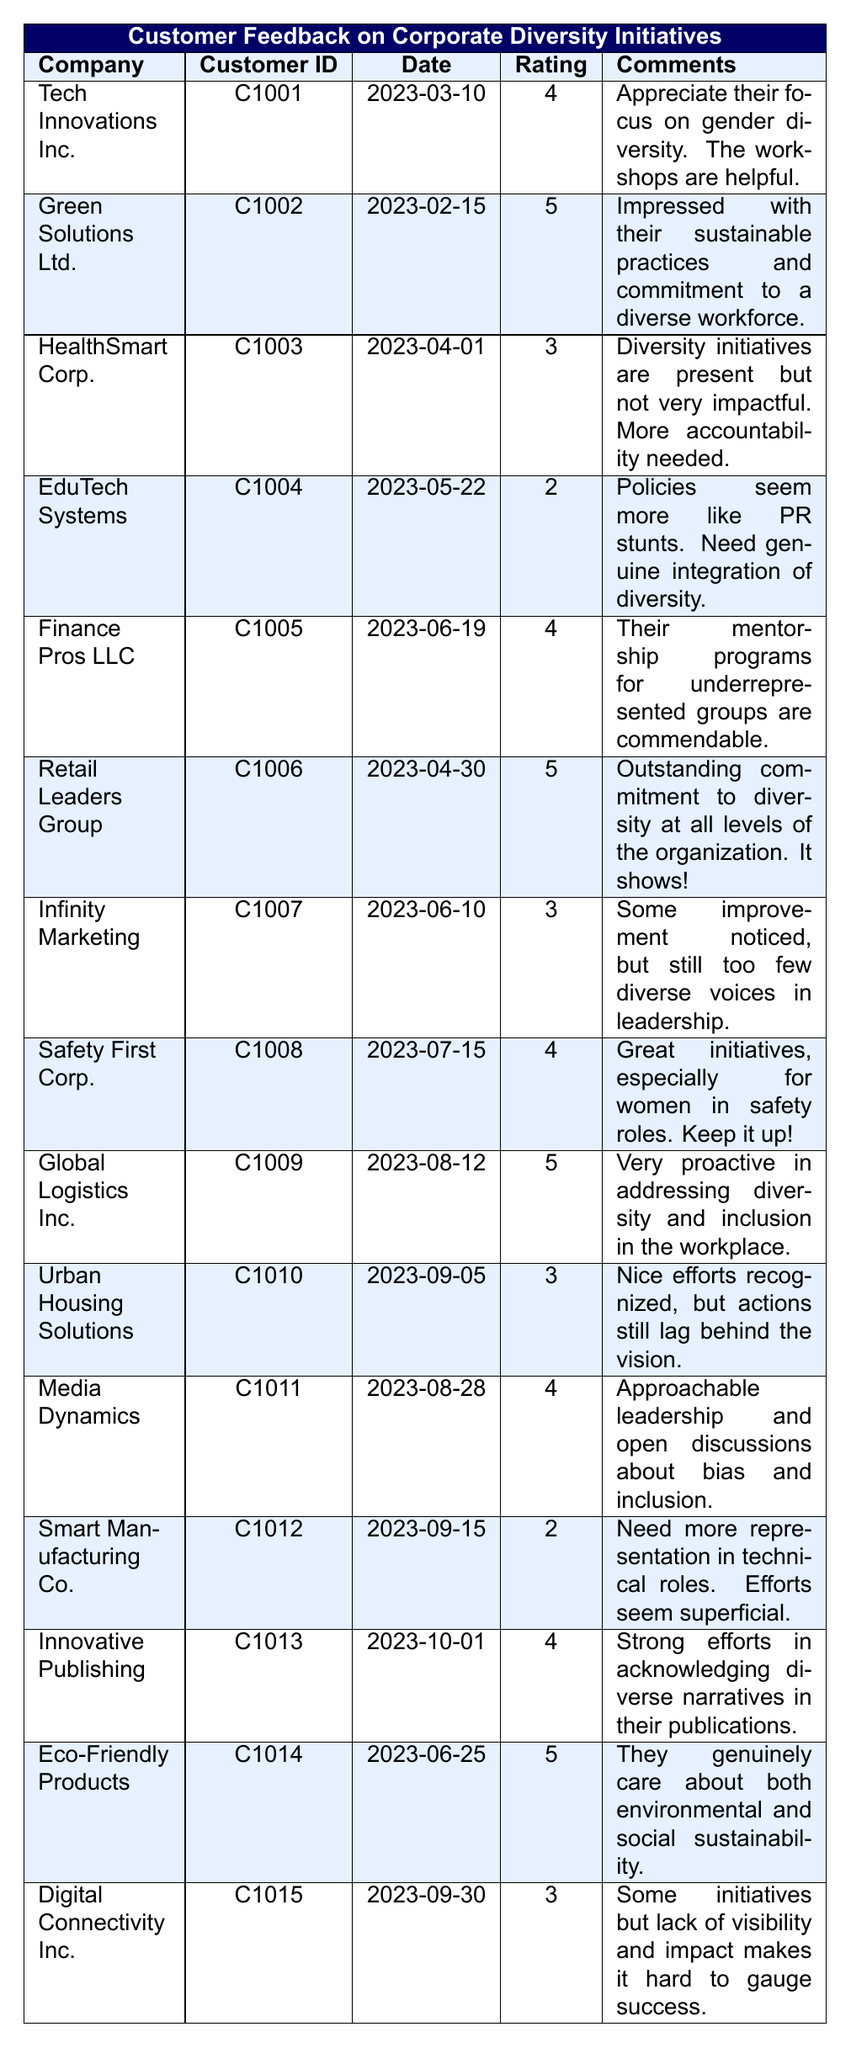What is the highest rating given to a company in the table? The highest rating is 5, as seen for several companies: Green Solutions Ltd., Retail Leaders Group, Global Logistics Inc., and Eco-Friendly Products.
Answer: 5 Which company received a rating of 2? The table shows that EduTech Systems and Smart Manufacturing Co. both received a rating of 2.
Answer: EduTech Systems, Smart Manufacturing Co How many companies have a rating of 4? The companies with a rating of 4 are: Tech Innovations Inc., Finance Pros LLC, Safety First Corp., Media Dynamics, and Innovative Publishing, totaling 5 companies.
Answer: 5 Did any company receive a rating of 1? After checking all the ratings in the table, none of the companies rated received a rating of 1.
Answer: No What percentage of companies rated 5 out of the total number of companies? There are 5 companies with a rating of 5 out of a total of 15 companies. To find the percentage: (5/15) * 100 = 33.33%.
Answer: 33.33% Which feedback comments express skepticism about diversity initiatives? The comments from HealthSmart Corp. and EduTech Systems express skepticism. HealthSmart mentions the initiatives are not impactful and EduTech suggests they seem like PR stunts.
Answer: HealthSmart Corp., EduTech Systems Which company received feedback on the effectiveness of its female workforce initiatives? Safety First Corp. received positive feedback regarding its initiatives for women in safety roles.
Answer: Safety First Corp What is the average rating of companies in the table? The ratings are 4, 5, 3, 2, 4, 5, 3, 4, 5, 3, 4, 2, 4, 5, and 3, totaling 51 and average rating is 51/15 = 3.4.
Answer: 3.4 Which company received the most recent feedback based on the date? The most recent feedback date is 2023-10-01 from Innovative Publishing.
Answer: Innovative Publishing Are there more companies with ratings of 3 than companies with ratings of 2? There are 5 companies with a rating of 3 (HealthSmart Corp., Infinity Marketing, Urban Housing Solutions, Digital Connectivity Inc.) and 2 companies with a rating of 2 (EduTech Systems, Smart Manufacturing Co.), so yes, there are more.
Answer: Yes 